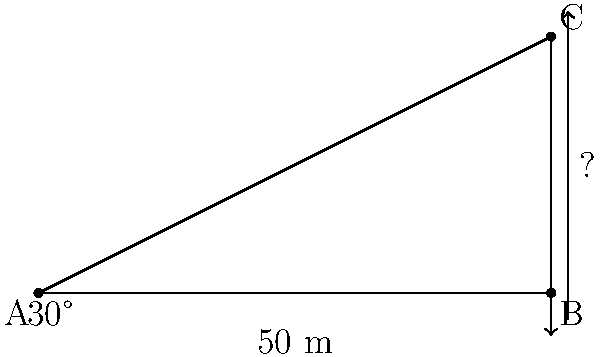You are visiting the Masjid al-Haram in Mecca and notice one of its minarets. Standing 50 meters away from the base of the minaret, you observe that the angle of elevation to the top of the minaret is 30°. What is the height of the minaret? To solve this problem, we can use the tangent function from trigonometry. Let's approach this step-by-step:

1) In a right-angled triangle, tangent of an angle is the ratio of the opposite side to the adjacent side.

2) In this case:
   - The angle of elevation is 30°
   - The adjacent side (distance from you to the base of the minaret) is 50 meters
   - The opposite side (height of the minaret) is what we're trying to find

3) We can write this as an equation:
   $\tan(30°) = \frac{\text{height}}{\text{distance}}$

4) Substituting the known values:
   $\tan(30°) = \frac{\text{height}}{50}$

5) To solve for height, multiply both sides by 50:
   $50 \cdot \tan(30°) = \text{height}$

6) Now, we need to calculate this:
   $\tan(30°) \approx 0.5773$

7) So, the height is:
   $\text{height} = 50 \cdot 0.5773 \approx 28.87$ meters

Therefore, the height of the minaret is approximately 28.87 meters.
Answer: $28.87$ meters 